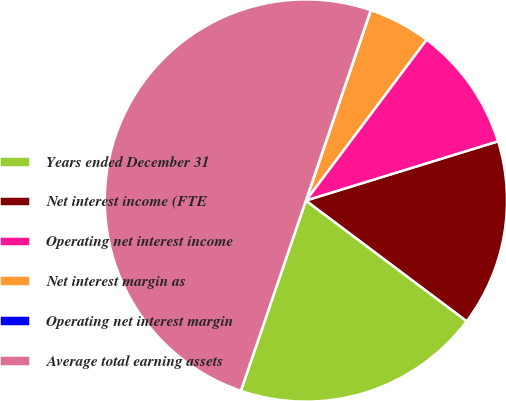<chart> <loc_0><loc_0><loc_500><loc_500><pie_chart><fcel>Years ended December 31<fcel>Net interest income (FTE<fcel>Operating net interest income<fcel>Net interest margin as<fcel>Operating net interest margin<fcel>Average total earning assets<nl><fcel>20.0%<fcel>15.0%<fcel>10.0%<fcel>5.01%<fcel>0.01%<fcel>49.98%<nl></chart> 